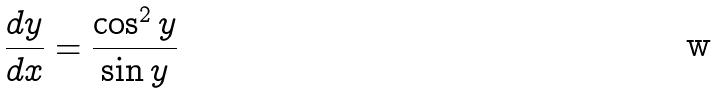<formula> <loc_0><loc_0><loc_500><loc_500>\frac { d y } { d x } = \frac { \cos ^ { 2 } y } { \sin y }</formula> 